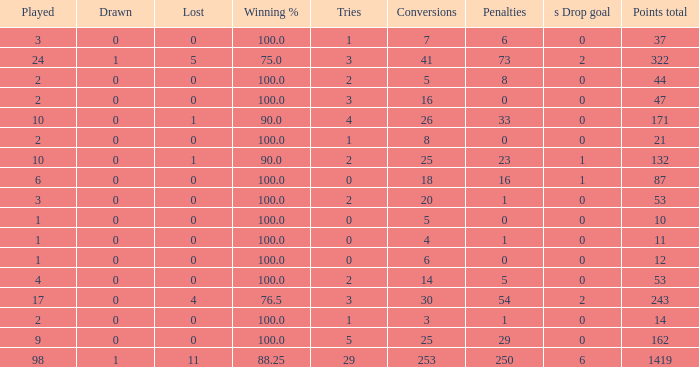What is the lowest number of penalties he obtained when his score surpassed 1419 in more than 98 games? None. 